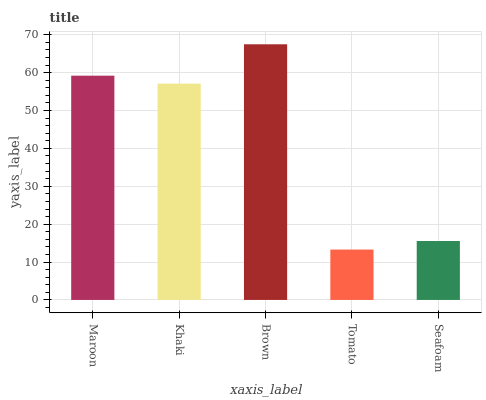Is Khaki the minimum?
Answer yes or no. No. Is Khaki the maximum?
Answer yes or no. No. Is Maroon greater than Khaki?
Answer yes or no. Yes. Is Khaki less than Maroon?
Answer yes or no. Yes. Is Khaki greater than Maroon?
Answer yes or no. No. Is Maroon less than Khaki?
Answer yes or no. No. Is Khaki the high median?
Answer yes or no. Yes. Is Khaki the low median?
Answer yes or no. Yes. Is Seafoam the high median?
Answer yes or no. No. Is Seafoam the low median?
Answer yes or no. No. 